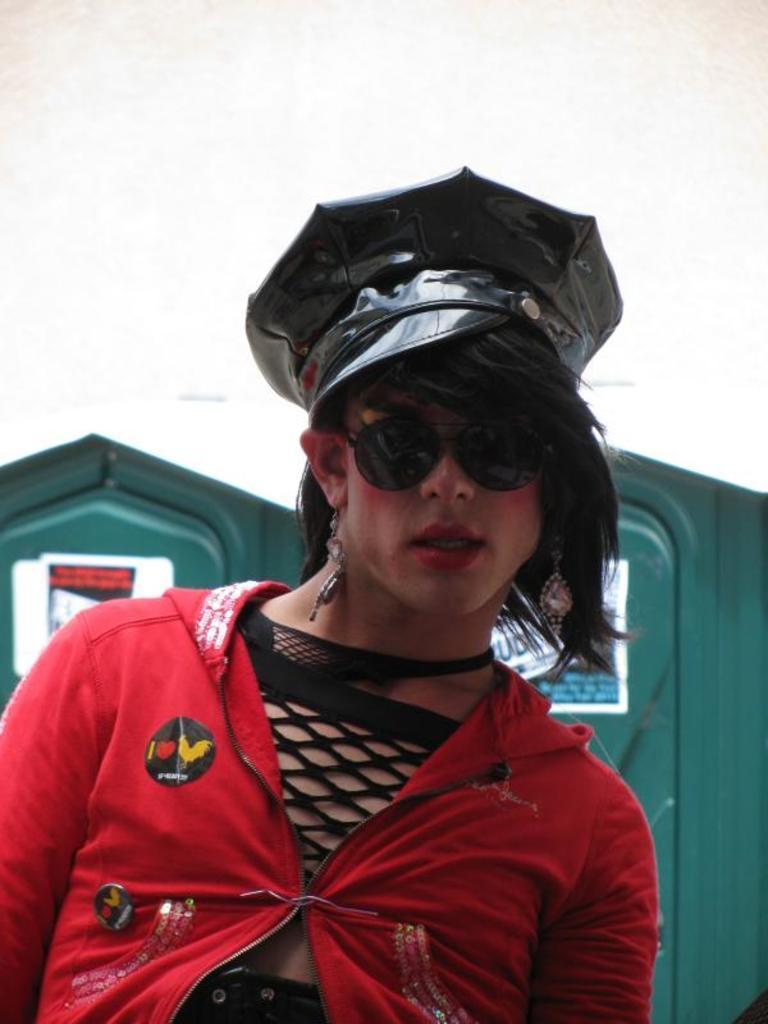How would you summarize this image in a sentence or two? In this image I can see there is a woman standing and she is wearing a cap, there is a green color wall in the backdrop. 